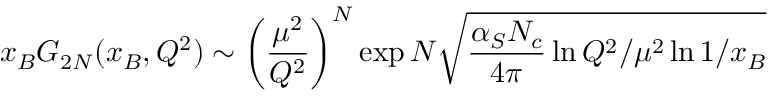<formula> <loc_0><loc_0><loc_500><loc_500>x _ { B } G _ { 2 N } ( x _ { B } , Q ^ { 2 } ) \sim \left ( \frac { \mu ^ { 2 } } { Q ^ { 2 } } \right ) ^ { N } \exp N \sqrt { \frac { \alpha _ { S } N _ { c } } { 4 \pi } \ln Q ^ { 2 } / \mu ^ { 2 } \ln 1 / x _ { B } }</formula> 